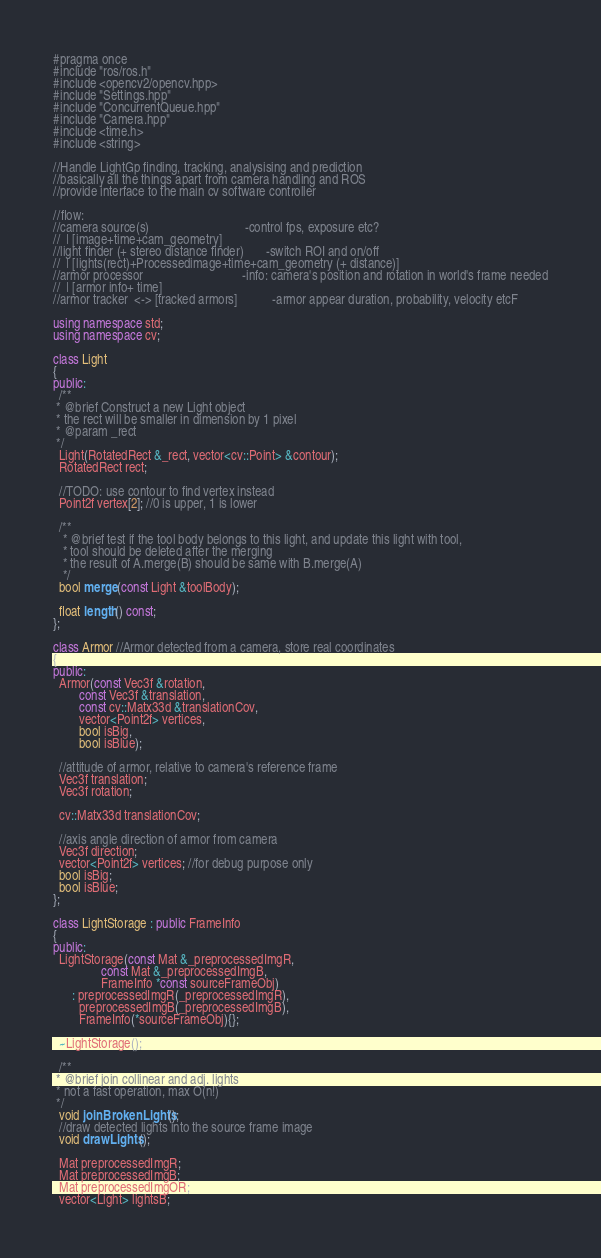Convert code to text. <code><loc_0><loc_0><loc_500><loc_500><_C++_>#pragma once
#include "ros/ros.h"
#include <opencv2/opencv.hpp>
#include "Settings.hpp"
#include "ConcurrentQueue.hpp"
#include "Camera.hpp"
#include <time.h>
#include <string>

//Handle LightGp finding, tracking, analysising and prediction
//basically all the things apart from camera handling and ROS
//provide interface to the main cv software controller

//flow:
//camera source(s)                              -control fps, exposure etc?
//  | [image+time+cam_geometry]
//light finder (+ stereo distance finder)       -switch ROI and on/off
//  | [lights(rect)+Processedimage+time+cam_geometry (+ distance)]
//armor processor                               -info: camera's position and rotation in world's frame needed
//  | [armor info+ time]
//armor tracker  <-> [tracked armors]           -armor appear duration, probability, velocity etcF

using namespace std;
using namespace cv;

class Light
{
public:
  /**
 * @brief Construct a new Light object
 * the rect will be smaller in dimension by 1 pixel
 * @param _rect
 */
  Light(RotatedRect &_rect, vector<cv::Point> &contour);
  RotatedRect rect;

  //TODO: use contour to find vertex instead
  Point2f vertex[2]; //0 is upper, 1 is lower

  /**
   * @brief test if the tool body belongs to this light, and update this light with tool,
   * tool should be deleted after the merging
   * the result of A.merge(B) should be same with B.merge(A)
   */
  bool merge(const Light &toolBody);

  float length() const;
};

class Armor //Armor detected from a camera, store real coordinates
{
public:
  Armor(const Vec3f &rotation,
        const Vec3f &translation,
        const cv::Matx33d &translationCov,
        vector<Point2f> vertices,
        bool isBig,
        bool isBlue);

  //attitude of armor, relative to camera's reference frame
  Vec3f translation;
  Vec3f rotation;

  cv::Matx33d translationCov;

  //axis angle direction of armor from camera
  Vec3f direction;
  vector<Point2f> vertices; //for debug purpose only
  bool isBig;
  bool isBlue;
};

class LightStorage : public FrameInfo
{
public:
  LightStorage(const Mat &_preprocessedImgR,
               const Mat &_preprocessedImgB,
               FrameInfo *const sourceFrameObj)
      : preprocessedImgR(_preprocessedImgR),
        preprocessedImgB(_preprocessedImgB),
        FrameInfo(*sourceFrameObj){};

  ~LightStorage();

  /**
 * @brief join collinear and adj. lights
 * not a fast operation, max O(n!)
 */
  void joinBrokenLights();
  //draw detected lights into the source frame image
  void drawLights();

  Mat preprocessedImgR;
  Mat preprocessedImgB;
  Mat preprocessedImgOR;
  vector<Light> lightsB;</code> 